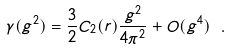<formula> <loc_0><loc_0><loc_500><loc_500>\gamma ( g ^ { 2 } ) = \frac { 3 } { 2 } C _ { 2 } ( r ) \frac { g ^ { 2 } } { 4 \pi ^ { 2 } } + O ( g ^ { 4 } ) \ .</formula> 